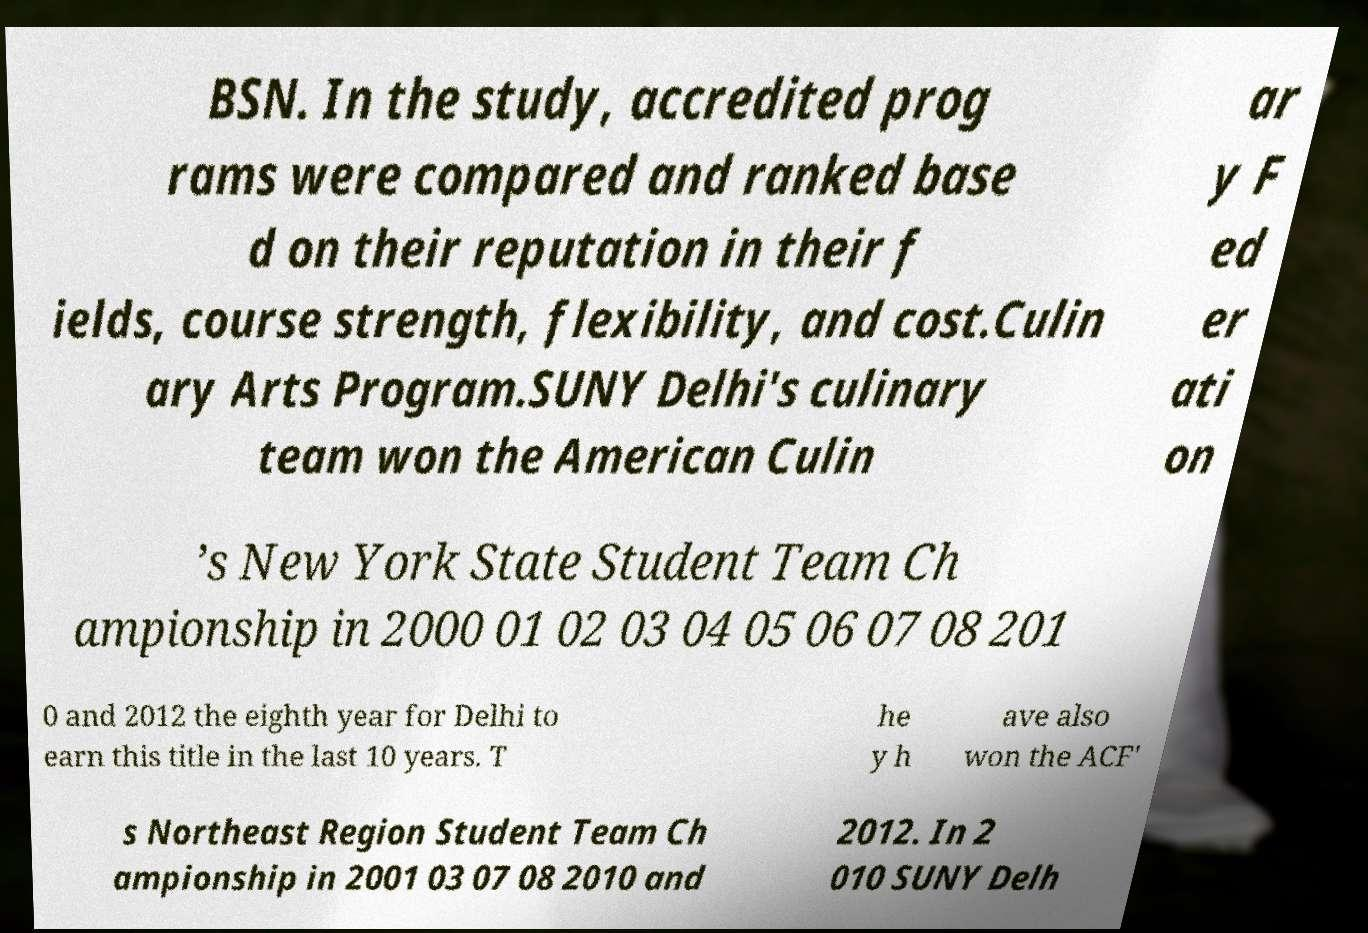Please read and relay the text visible in this image. What does it say? BSN. In the study, accredited prog rams were compared and ranked base d on their reputation in their f ields, course strength, flexibility, and cost.Culin ary Arts Program.SUNY Delhi's culinary team won the American Culin ar y F ed er ati on ’s New York State Student Team Ch ampionship in 2000 01 02 03 04 05 06 07 08 201 0 and 2012 the eighth year for Delhi to earn this title in the last 10 years. T he y h ave also won the ACF' s Northeast Region Student Team Ch ampionship in 2001 03 07 08 2010 and 2012. In 2 010 SUNY Delh 